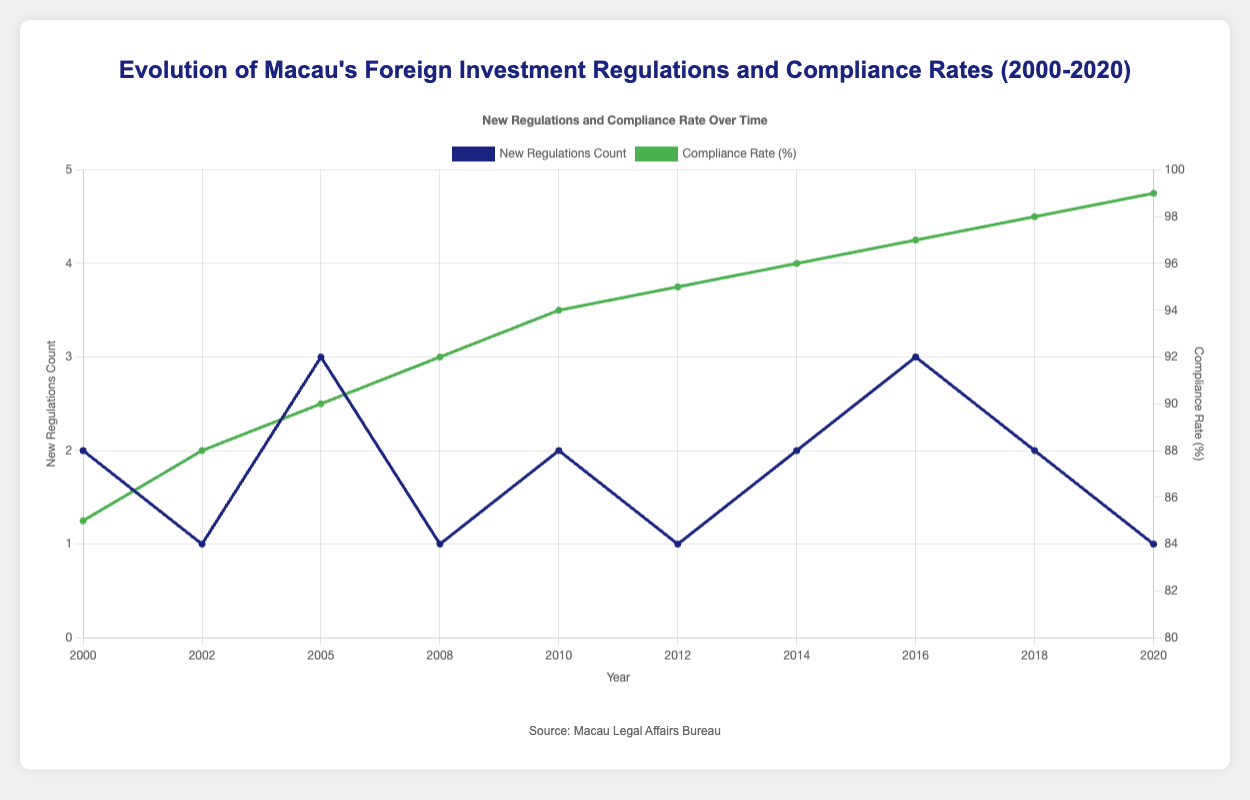What year had the highest compliance rate, and what was the rate? To determine the highest compliance rate, we examine the dataset or plot for the year with the maximum value in the "Compliance Rate (%)" series. The highest compliance rate of 99% occurred in 2020.
Answer: 2020, 99% How many new regulations were introduced in total between 2000 and 2020? To find the total number of new regulations introduced from 2000 to 2020, sum the "New Regulations Count" across all years: 2+1+3+1+2+1+2+3+2+1 = 18.
Answer: 18 Between 2000 and 2010, which year had the highest compliance rate, and what was it? Check the "Compliance Rate (%)" from 2000 to 2010. The highest compliance rate during this period is 94% in 2010.
Answer: 2010, 94% Which year had the largest number of new regulations, and how many were introduced? Identify the year with the maximum value in the "New Regulations Count" series. The year 2005 had the largest number of new regulations with a count of 3.
Answer: 2005, 3 Is there a general trend in the compliance rate from 2000 to 2020? Observe the compliance rate values over time. There is a clear upward trend, indicating that compliance rates increased steadily from 85% in 2000 to 99% in 2020.
Answer: Upward trend Compare the compliance rates between 2000 and 2018. By how many percentage points did it change? Subtract the compliance rate in 2000 (85%) from the compliance rate in 2018 (98%) to determine the change: 98 - 85 = 13 percentage points.
Answer: 13 percentage points How many years recorded an introduction of only one new regulation? Count the years in which "New Regulations Count" equals 1. The years are 2002, 2008, 2012, and 2020, totaling 4 years.
Answer: 4 What is the average number of new regulations introduced per year over the 20-year period? Calculate the average by summing all new regulations and dividing by the number of years. Sum = 18, Number of years = 10; Average = 18/10 = 1.8 regulations per year.
Answer: 1.8 Which year had both the highest compliance rate and the least number of new regulations? The year with the highest compliance rate (99%) and least number of new regulations (1) is 2020.
Answer: 2020 How many notable regulations were introduced in 2016, and what is their average compliance rate for that year? In 2016, there are three notable regulations. The compliance rate in 2016 is 97%. Therefore, the average compliance rate per notable regulation is 97% (same value as it’s the compliance rate for that year).
Answer: 3, 97% 